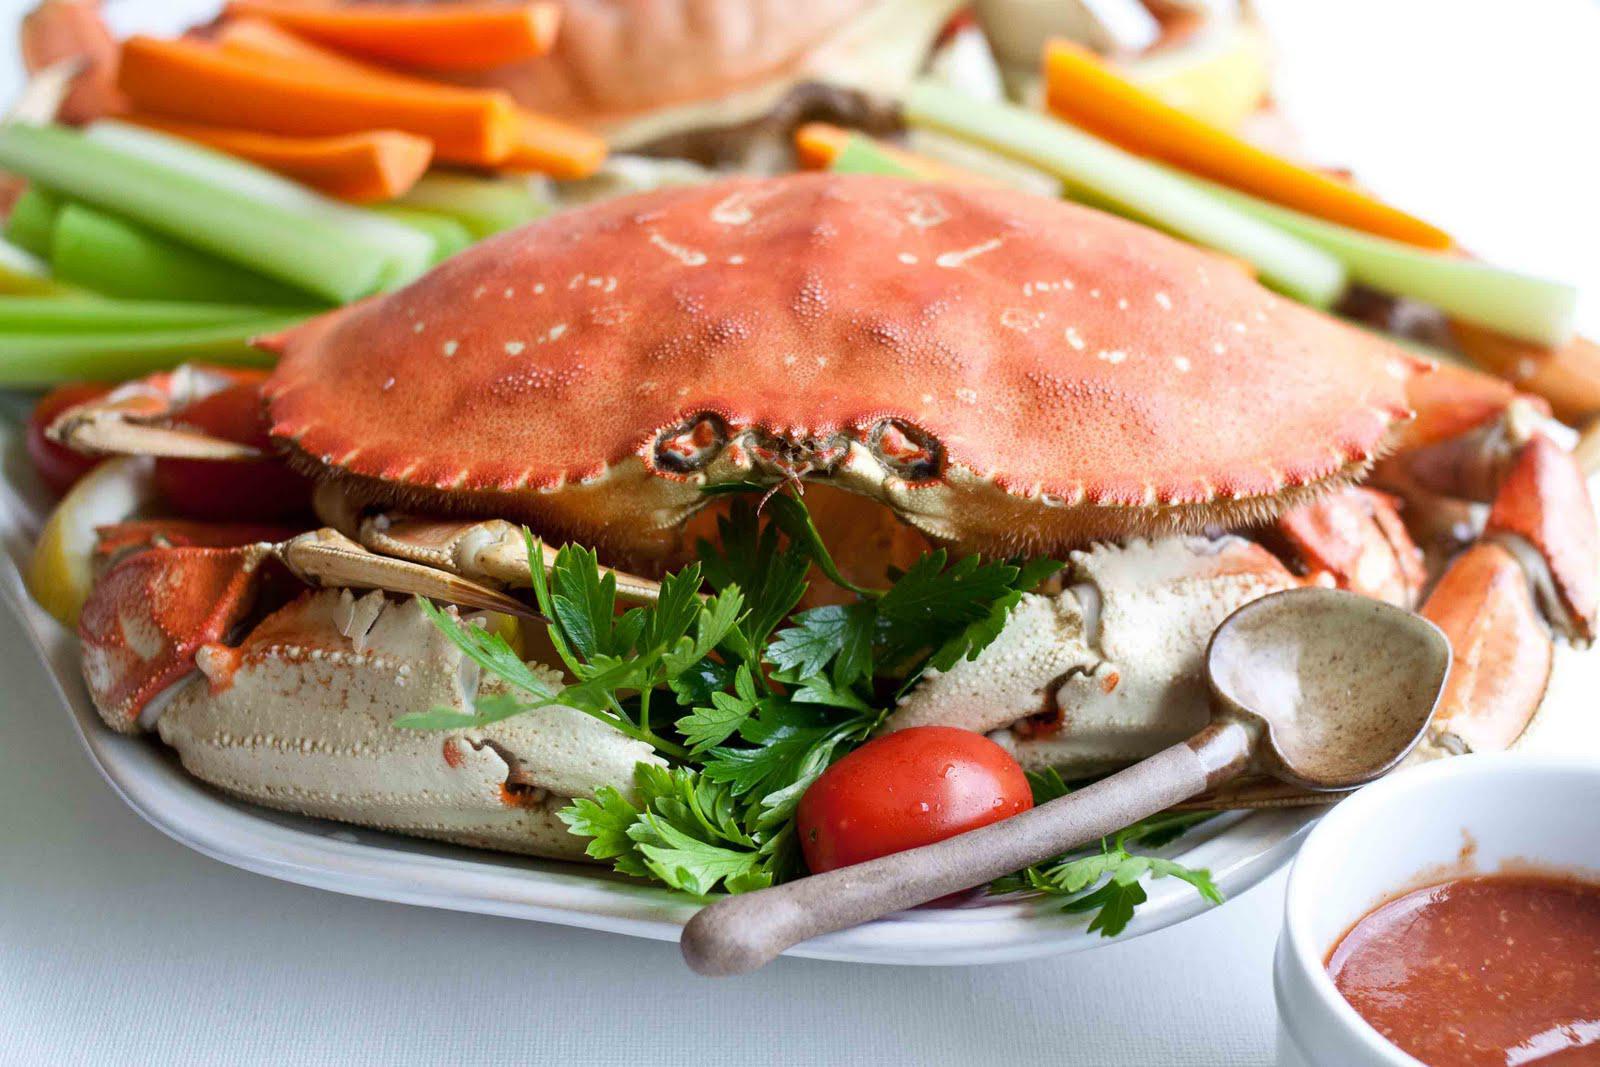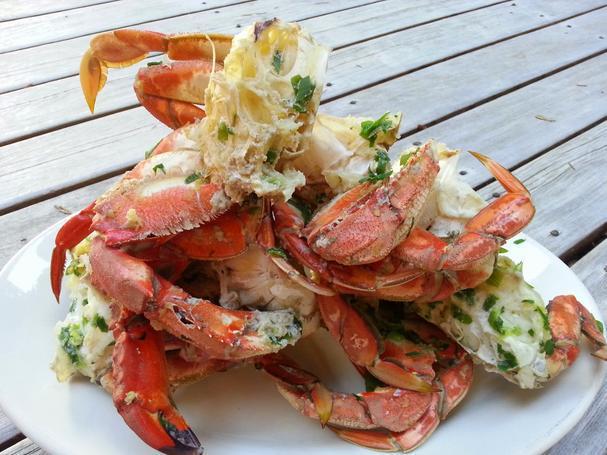The first image is the image on the left, the second image is the image on the right. For the images shown, is this caption "The crabs in each of the images are sitting in a round white plate." true? Answer yes or no. Yes. The first image is the image on the left, the second image is the image on the right. For the images displayed, is the sentence "In one image the entire crab is left intact, while the other image shows only pieces of a crab on a plate." factually correct? Answer yes or no. Yes. 